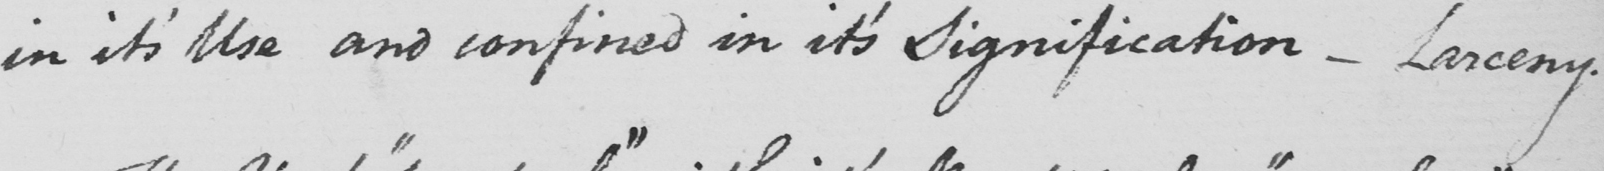Transcribe the text shown in this historical manuscript line. in it ' s Use and confined in it ' s Signification  _  Larceny . 